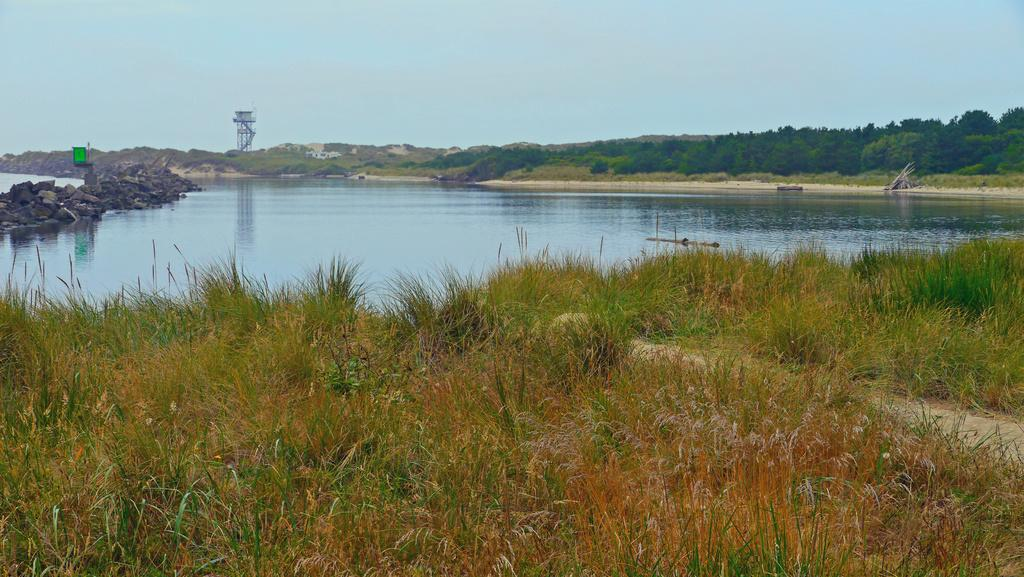What type of living organisms can be seen in the image? Plants can be seen in the image. What color are the plants? The plants are green. What can be seen in the background of the image? Water and rocks are visible in the background of the image. What structure is present in the image? There is a water tank in the image. What is the color of the sky in the image? The sky is blue. How many sails can be seen on the carriage in the image? There is no carriage or sail present in the image. 